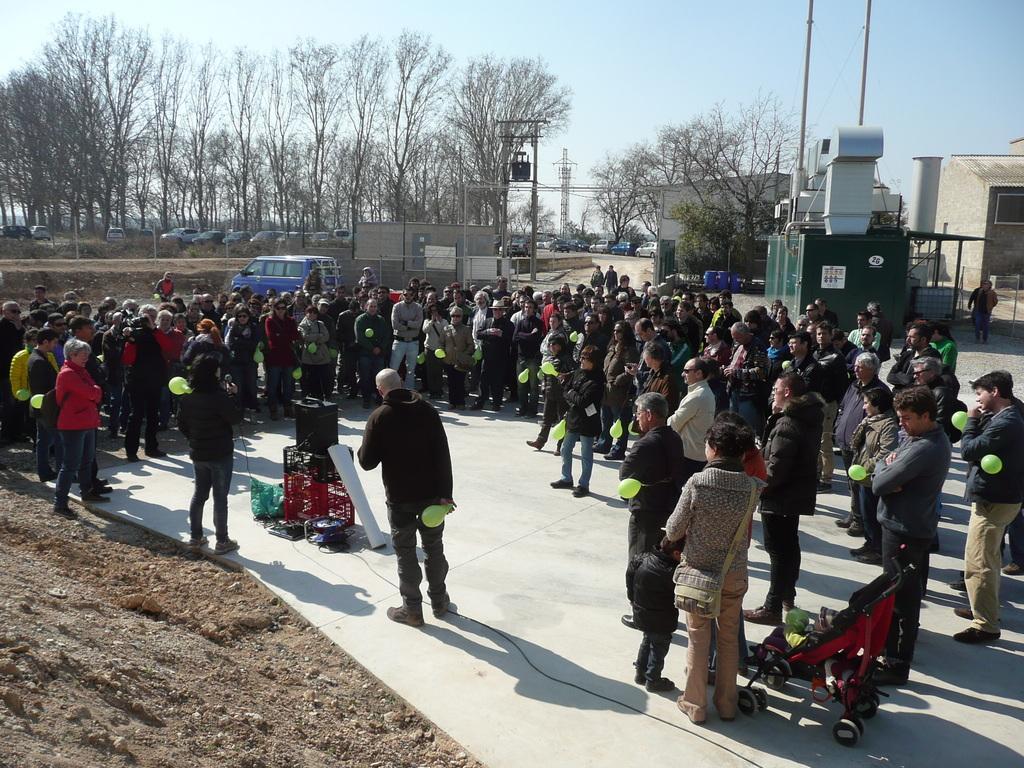Could you give a brief overview of what you see in this image? In this image, we can see people and some are holding balloons and we can see a trolley and some other objects on the road. In the background, there are vehicles, trees, poles along with wires and sheds and we can see a transformer and there is a fence. 